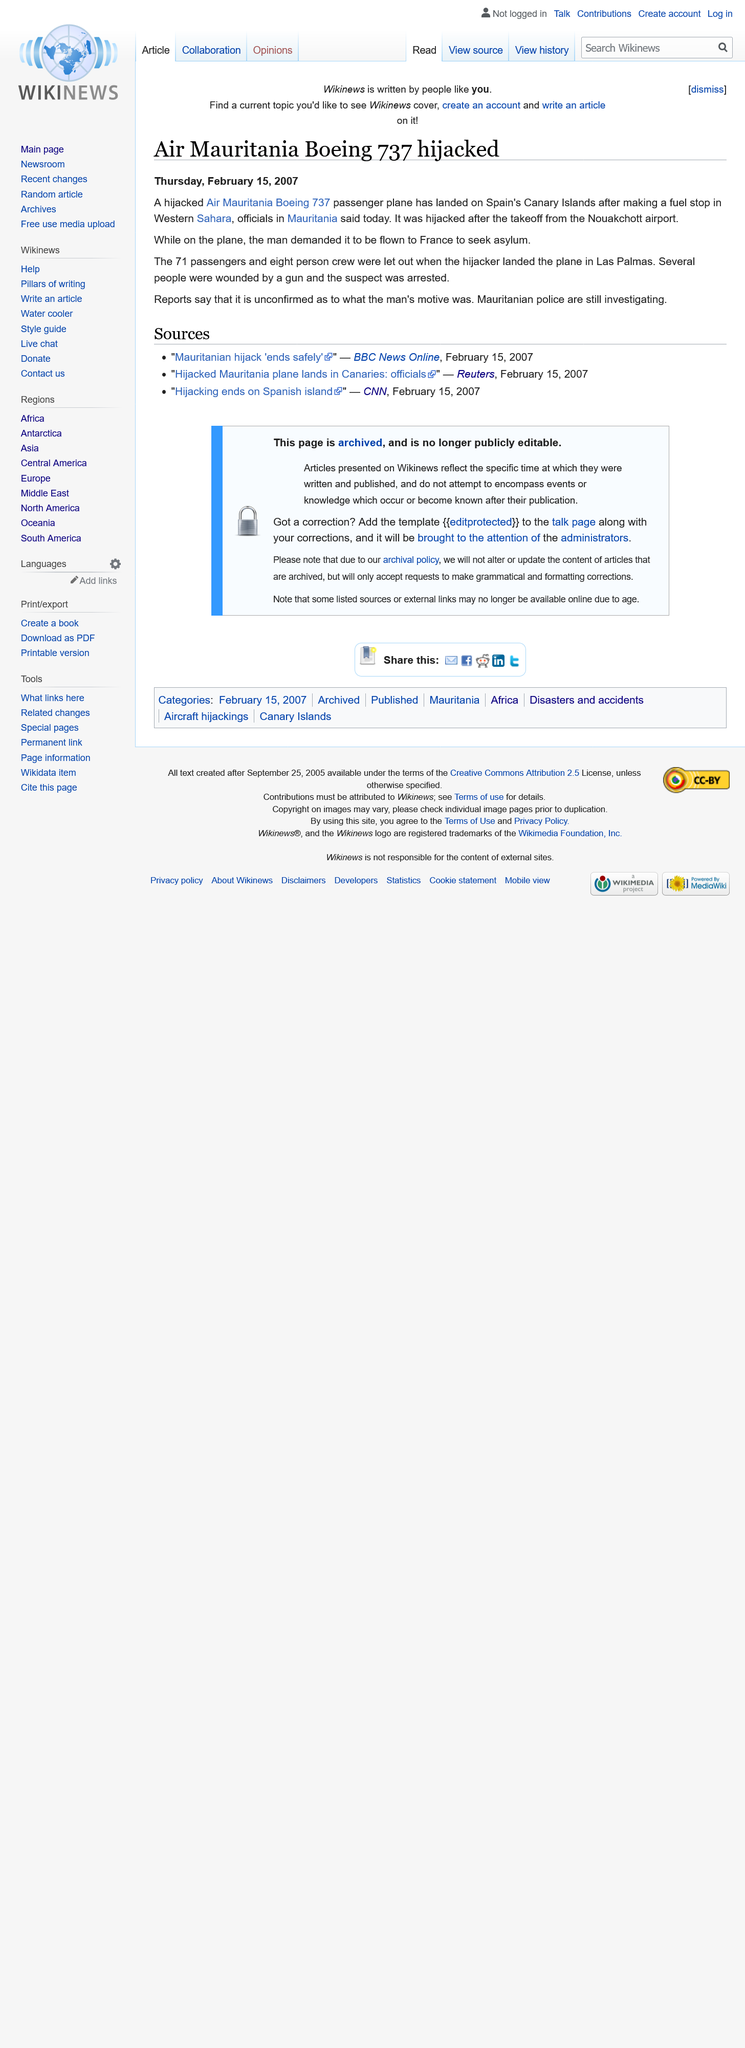Give some essential details in this illustration. There were 79 individuals on the hijacked plane, besides the hijacker. On March 24, 1973, a hijacking took place involving the Air Mauritania Boeing 737. The hijacker intended to fly to France. 